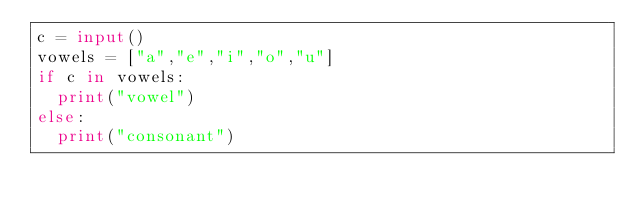<code> <loc_0><loc_0><loc_500><loc_500><_Python_>c = input()
vowels = ["a","e","i","o","u"]
if c in vowels:
  print("vowel")
else:
  print("consonant")</code> 